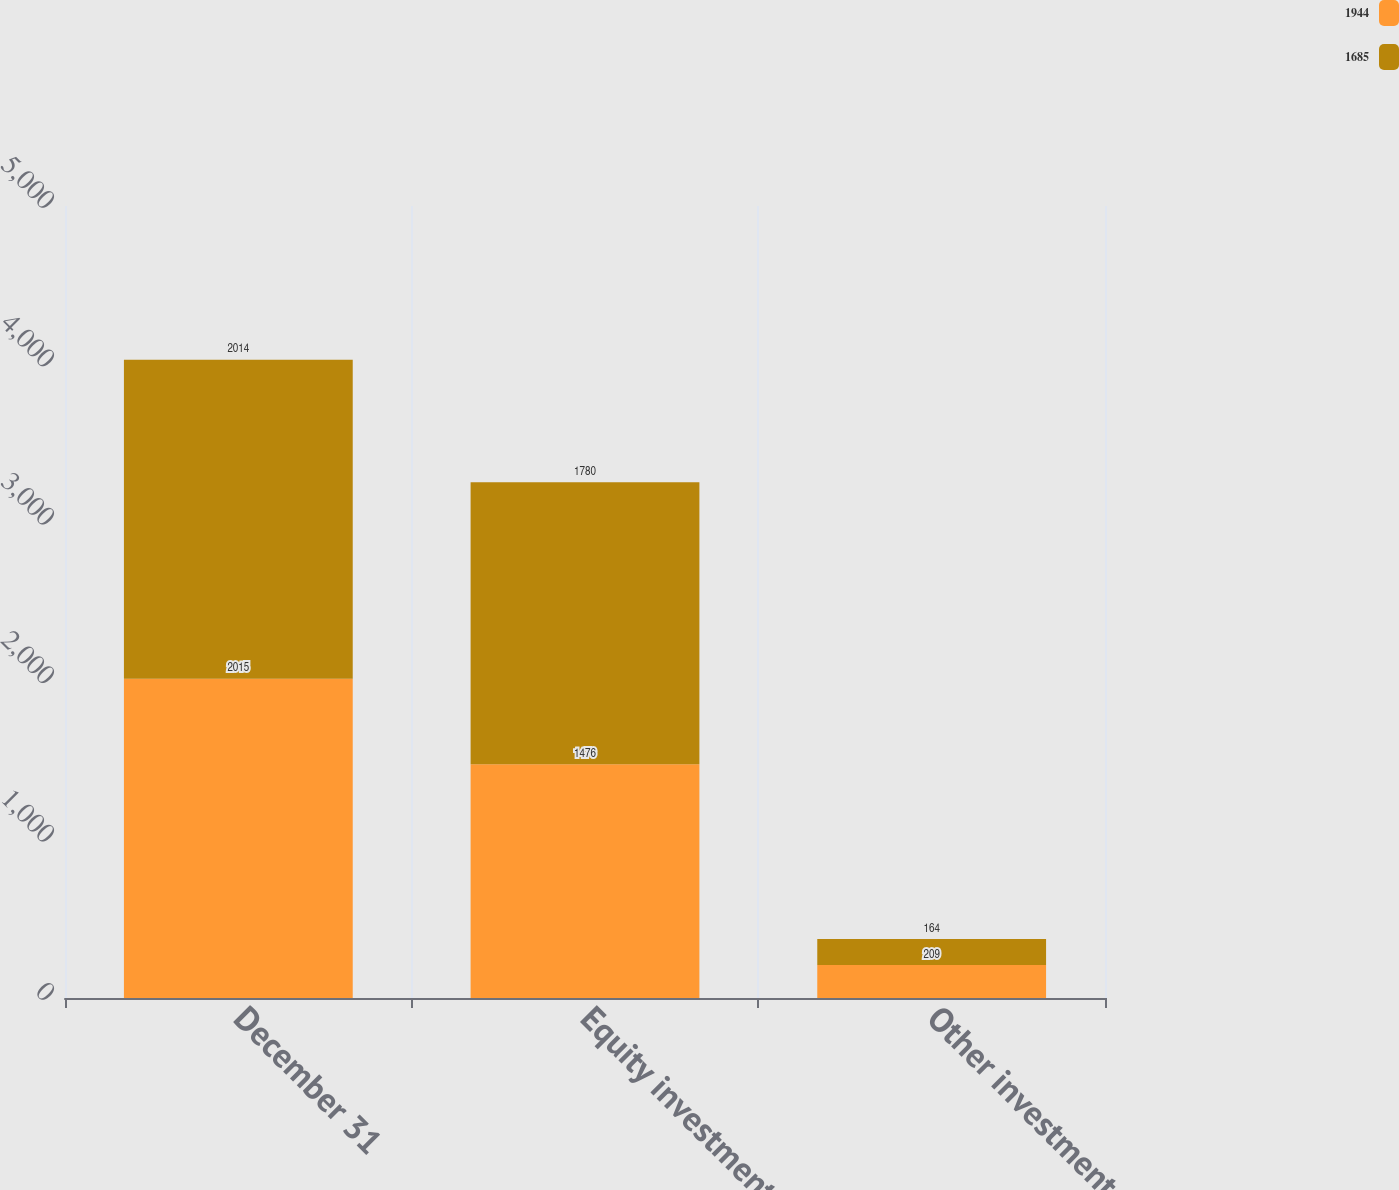Convert chart. <chart><loc_0><loc_0><loc_500><loc_500><stacked_bar_chart><ecel><fcel>December 31<fcel>Equity investments<fcel>Other investments<nl><fcel>1944<fcel>2015<fcel>1476<fcel>209<nl><fcel>1685<fcel>2014<fcel>1780<fcel>164<nl></chart> 